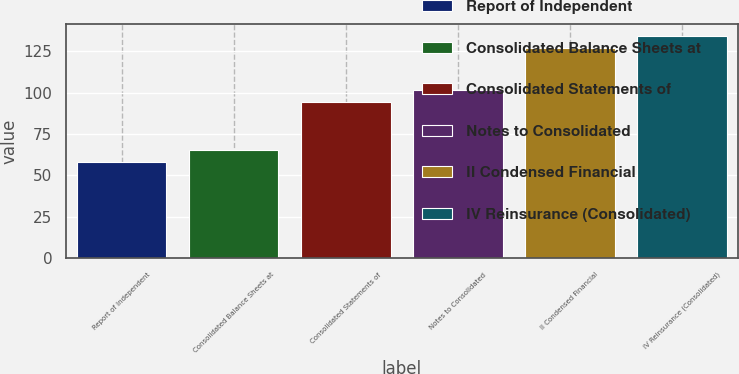Convert chart. <chart><loc_0><loc_0><loc_500><loc_500><bar_chart><fcel>Report of Independent<fcel>Consolidated Balance Sheets at<fcel>Consolidated Statements of<fcel>Notes to Consolidated<fcel>II Condensed Financial<fcel>IV Reinsurance (Consolidated)<nl><fcel>58<fcel>65.3<fcel>94.5<fcel>101.8<fcel>127<fcel>134.3<nl></chart> 